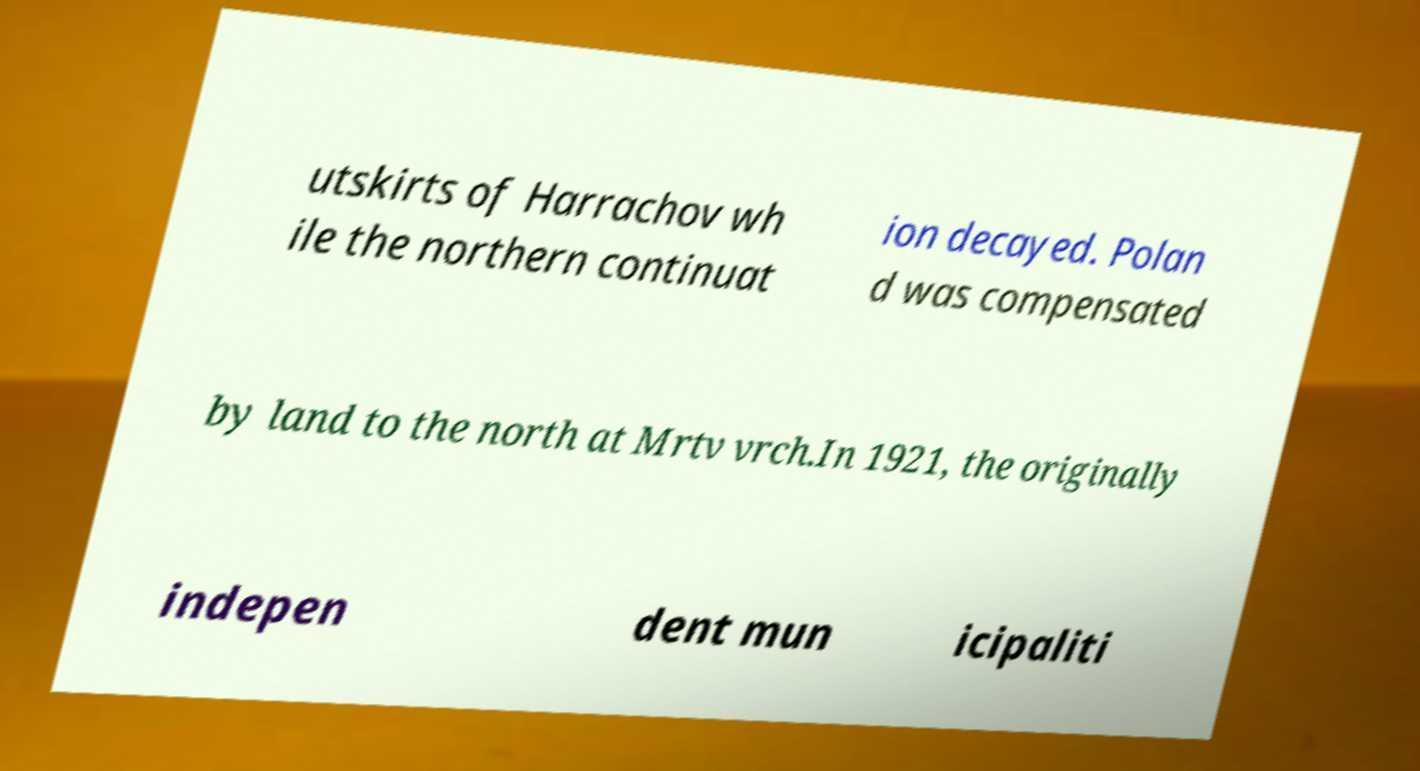What messages or text are displayed in this image? I need them in a readable, typed format. utskirts of Harrachov wh ile the northern continuat ion decayed. Polan d was compensated by land to the north at Mrtv vrch.In 1921, the originally indepen dent mun icipaliti 